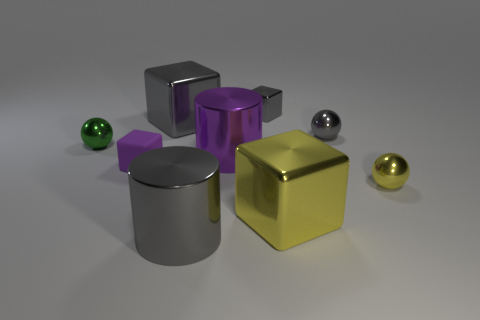Are there any other things that are made of the same material as the tiny purple thing?
Make the answer very short. No. What number of cylinders are the same color as the small rubber cube?
Provide a short and direct response. 1. The yellow metallic cube has what size?
Offer a terse response. Large. Do the tiny purple thing and the big gray shiny thing that is in front of the purple matte thing have the same shape?
Offer a very short reply. No. What is the color of the tiny cube that is the same material as the green sphere?
Give a very brief answer. Gray. There is a sphere that is behind the green shiny ball; how big is it?
Ensure brevity in your answer.  Small. Are there fewer large gray shiny cylinders on the right side of the yellow block than small gray metal things?
Your answer should be very brief. Yes. Does the tiny rubber block have the same color as the tiny shiny block?
Ensure brevity in your answer.  No. Are there any other things that are the same shape as the purple matte thing?
Provide a succinct answer. Yes. Is the number of tiny green balls less than the number of tiny red blocks?
Give a very brief answer. No. 